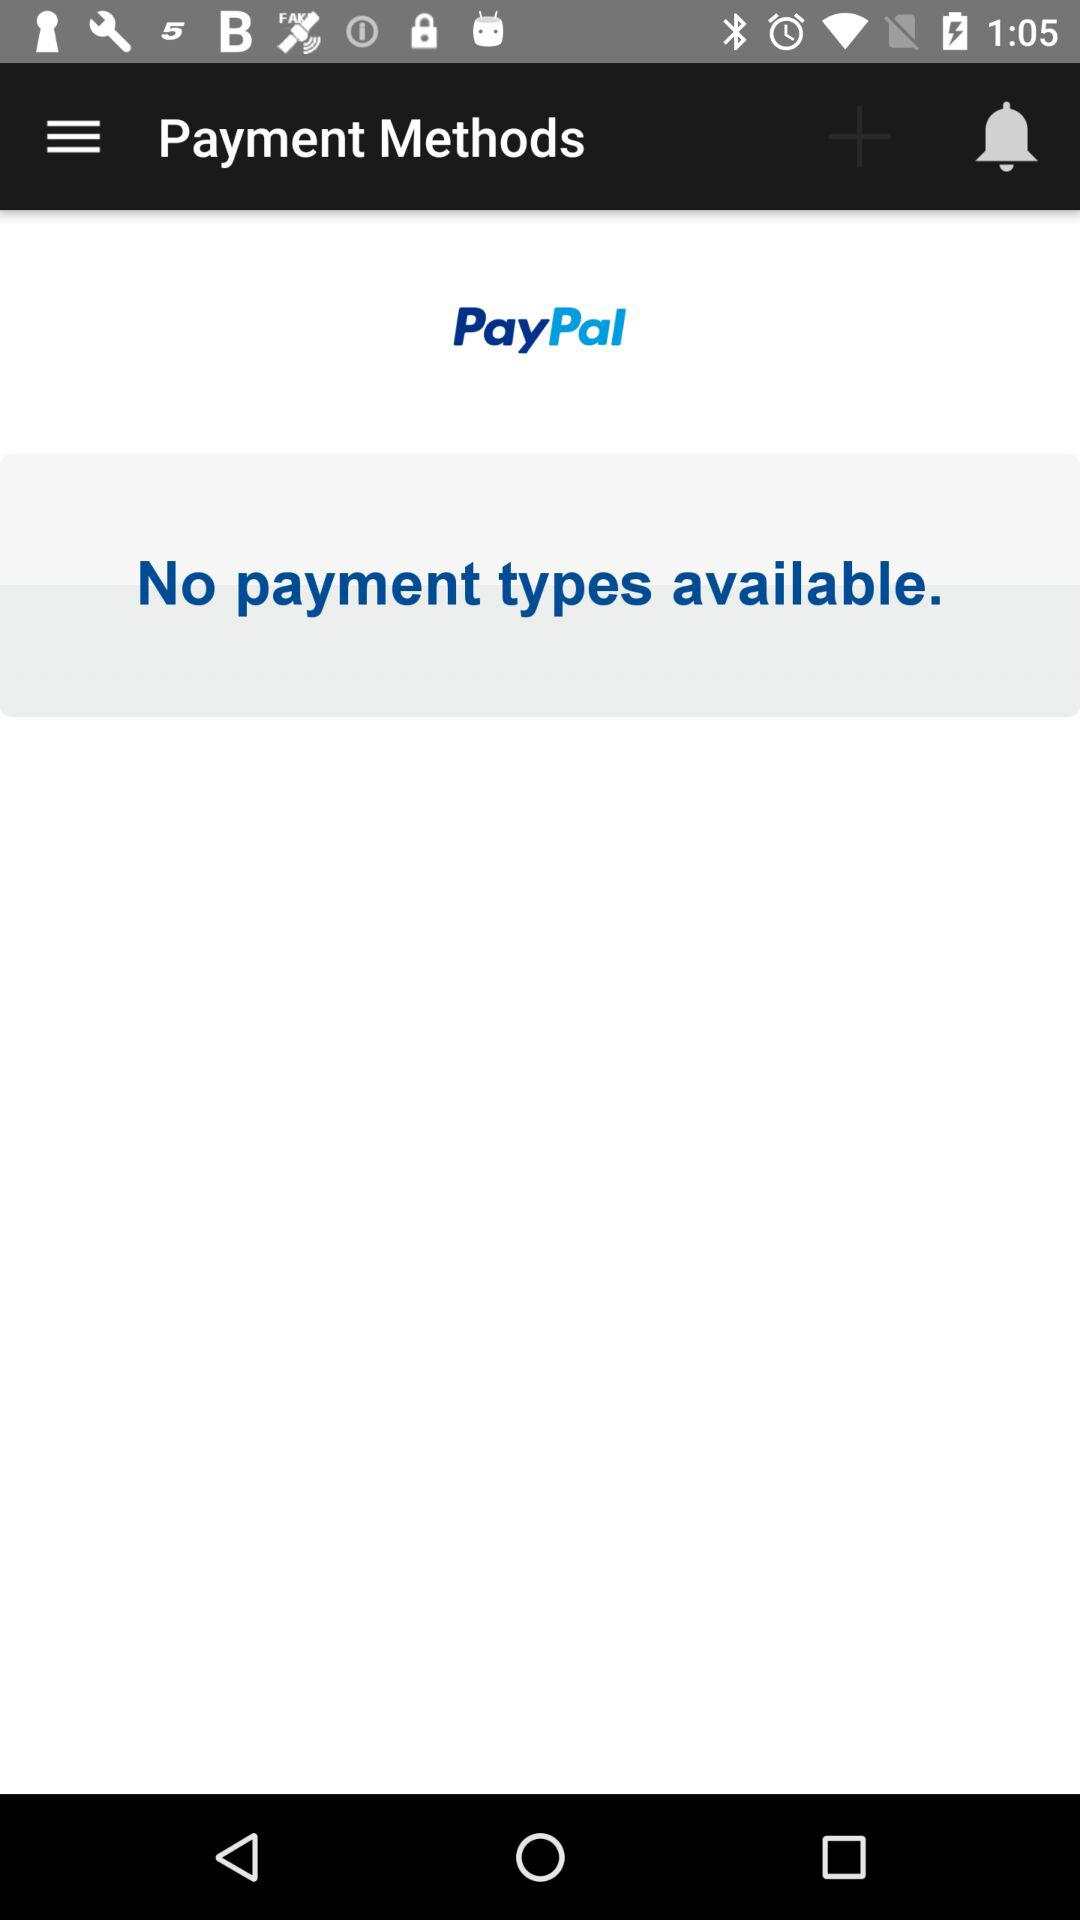How many payment types are available?
Answer the question using a single word or phrase. 1 